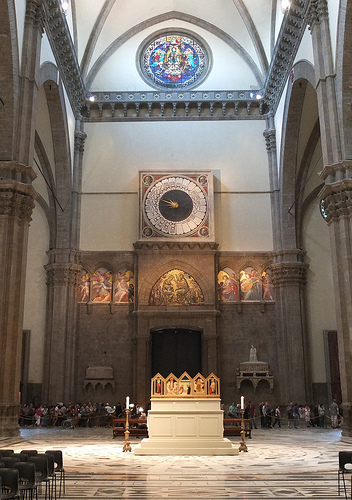Do you see a giraffe near the wall? No, there is no giraffe near the wall. 